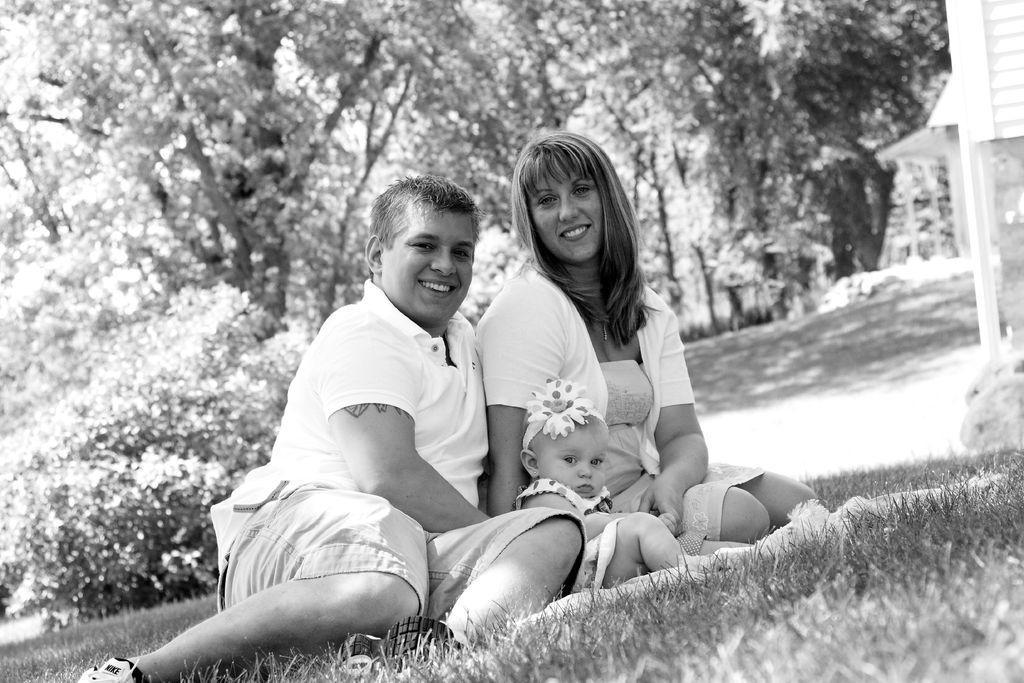Please provide a concise description of this image. This is a black and white image. In this image we can see two people sitting on grass. There is a baby. In the background of the image there are trees. At the bottom of the image there is grass. 